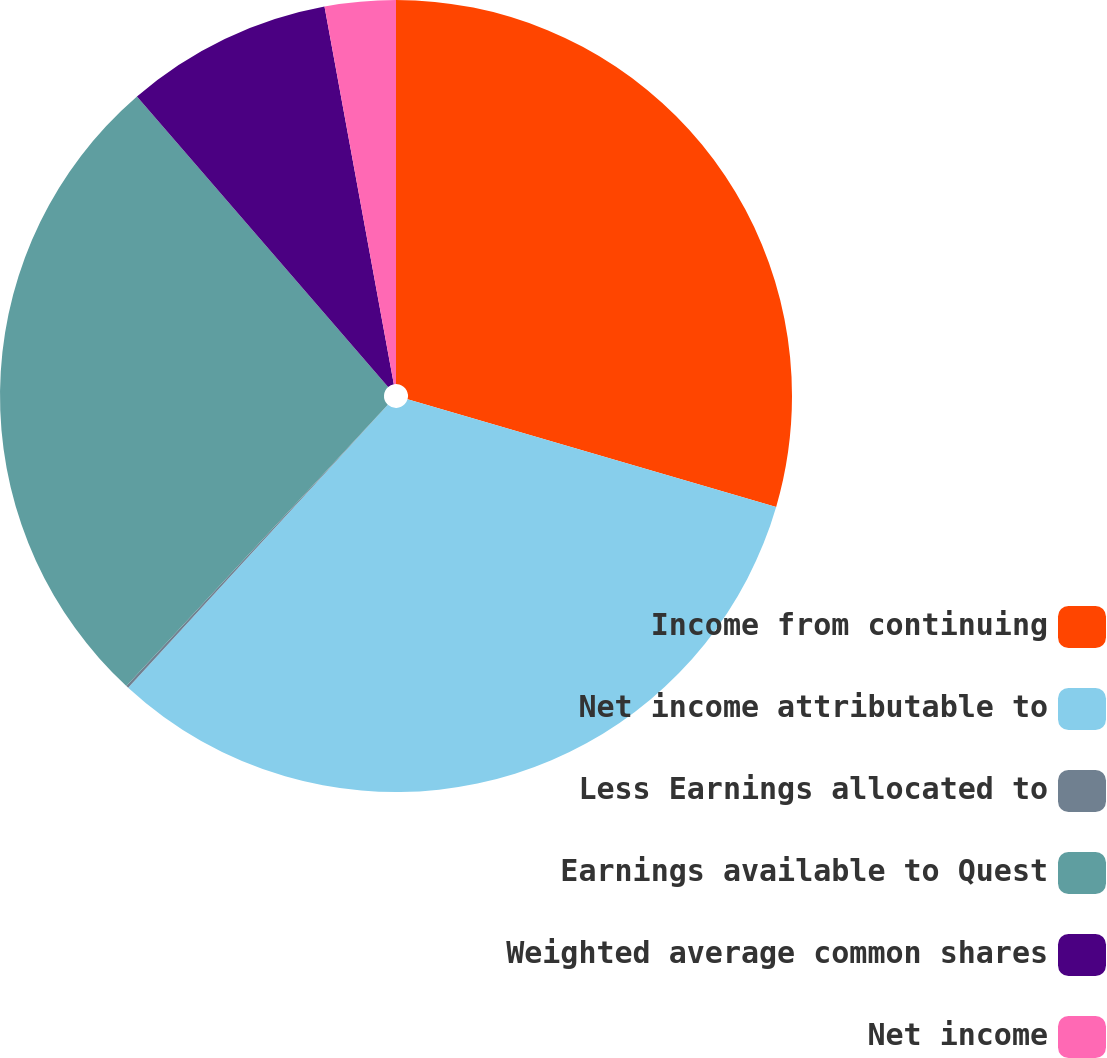Convert chart. <chart><loc_0><loc_0><loc_500><loc_500><pie_chart><fcel>Income from continuing<fcel>Net income attributable to<fcel>Less Earnings allocated to<fcel>Earnings available to Quest<fcel>Weighted average common shares<fcel>Net income<nl><fcel>29.52%<fcel>32.31%<fcel>0.1%<fcel>26.73%<fcel>8.46%<fcel>2.89%<nl></chart> 